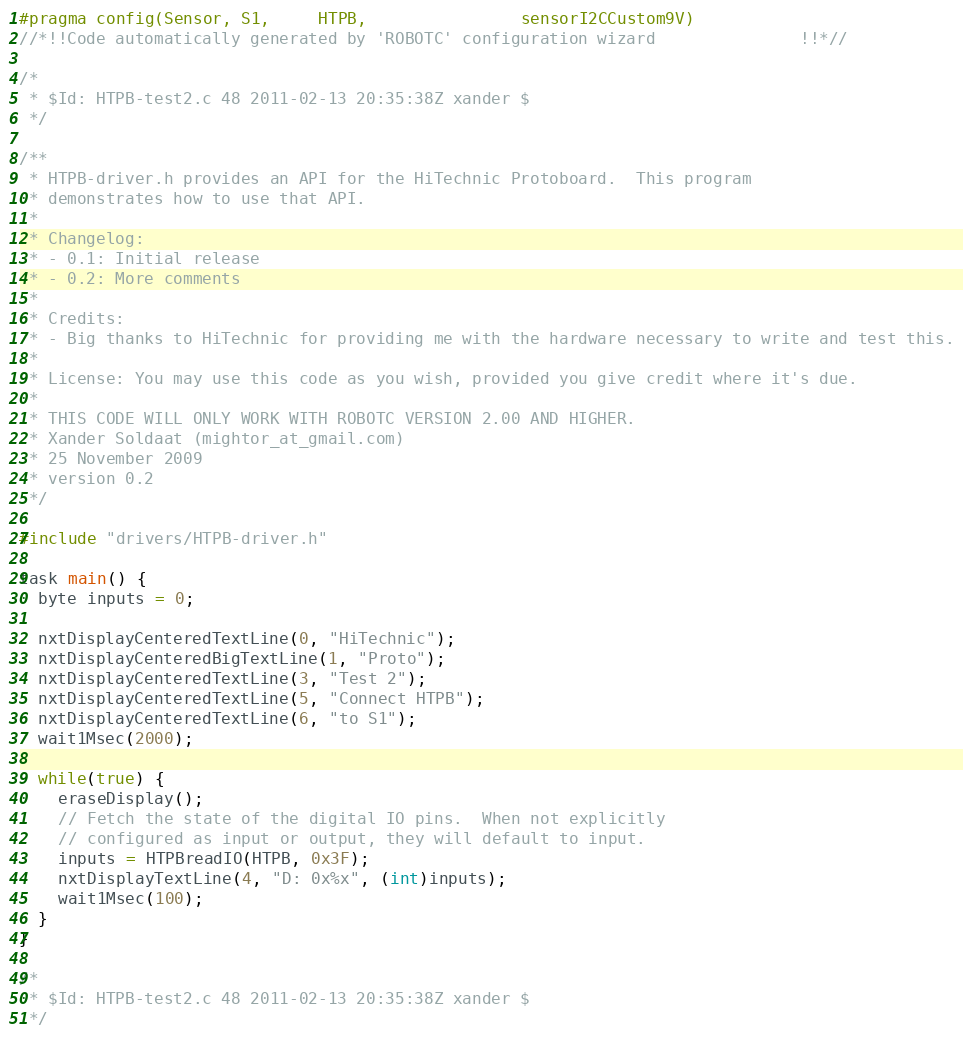Convert code to text. <code><loc_0><loc_0><loc_500><loc_500><_C_>#pragma config(Sensor, S1,     HTPB,                sensorI2CCustom9V)
//*!!Code automatically generated by 'ROBOTC' configuration wizard               !!*//

/*
 * $Id: HTPB-test2.c 48 2011-02-13 20:35:38Z xander $
 */

/**
 * HTPB-driver.h provides an API for the HiTechnic Protoboard.  This program
 * demonstrates how to use that API.
 *
 * Changelog:
 * - 0.1: Initial release
 * - 0.2: More comments
 *
 * Credits:
 * - Big thanks to HiTechnic for providing me with the hardware necessary to write and test this.
 *
 * License: You may use this code as you wish, provided you give credit where it's due.
 *
 * THIS CODE WILL ONLY WORK WITH ROBOTC VERSION 2.00 AND HIGHER.
 * Xander Soldaat (mightor_at_gmail.com)
 * 25 November 2009
 * version 0.2
 */

#include "drivers/HTPB-driver.h"

task main() {
  byte inputs = 0;

  nxtDisplayCenteredTextLine(0, "HiTechnic");
  nxtDisplayCenteredBigTextLine(1, "Proto");
  nxtDisplayCenteredTextLine(3, "Test 2");
  nxtDisplayCenteredTextLine(5, "Connect HTPB");
  nxtDisplayCenteredTextLine(6, "to S1");
  wait1Msec(2000);

  while(true) {
    eraseDisplay();
    // Fetch the state of the digital IO pins.  When not explicitly
    // configured as input or output, they will default to input.
    inputs = HTPBreadIO(HTPB, 0x3F);
    nxtDisplayTextLine(4, "D: 0x%x", (int)inputs);
    wait1Msec(100);
  }
}

/*
 * $Id: HTPB-test2.c 48 2011-02-13 20:35:38Z xander $
 */
</code> 